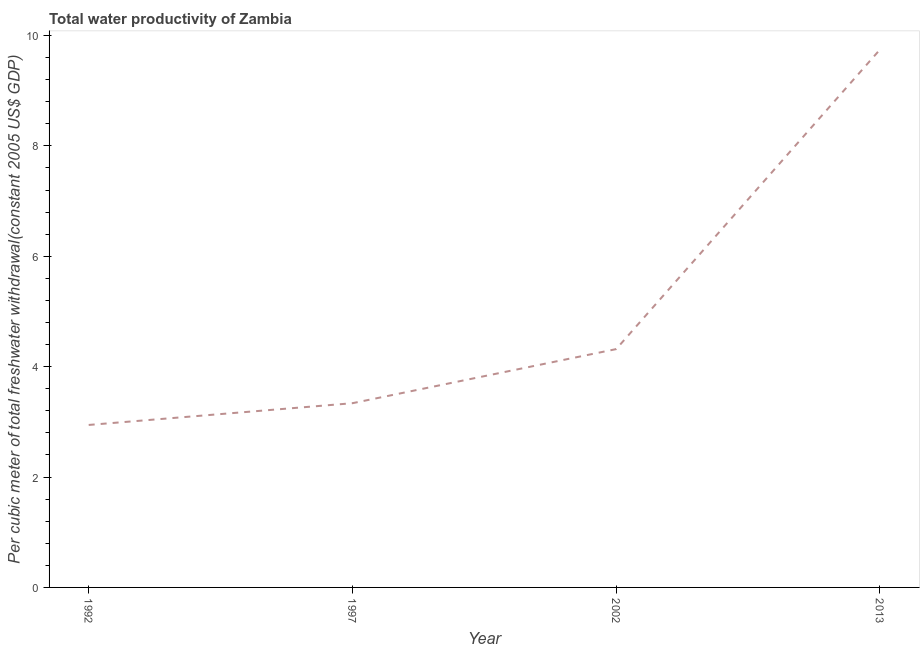What is the total water productivity in 1997?
Offer a terse response. 3.34. Across all years, what is the maximum total water productivity?
Your answer should be very brief. 9.74. Across all years, what is the minimum total water productivity?
Keep it short and to the point. 2.94. In which year was the total water productivity maximum?
Offer a terse response. 2013. What is the sum of the total water productivity?
Keep it short and to the point. 20.34. What is the difference between the total water productivity in 1992 and 1997?
Provide a short and direct response. -0.39. What is the average total water productivity per year?
Provide a short and direct response. 5.09. What is the median total water productivity?
Your response must be concise. 3.83. In how many years, is the total water productivity greater than 4 US$?
Provide a succinct answer. 2. Do a majority of the years between 1997 and 2002 (inclusive) have total water productivity greater than 1.6 US$?
Ensure brevity in your answer.  Yes. What is the ratio of the total water productivity in 2002 to that in 2013?
Provide a short and direct response. 0.44. Is the difference between the total water productivity in 1992 and 1997 greater than the difference between any two years?
Provide a succinct answer. No. What is the difference between the highest and the second highest total water productivity?
Your response must be concise. 5.43. Is the sum of the total water productivity in 1997 and 2002 greater than the maximum total water productivity across all years?
Offer a terse response. No. What is the difference between the highest and the lowest total water productivity?
Provide a short and direct response. 6.8. Does the total water productivity monotonically increase over the years?
Keep it short and to the point. Yes. Are the values on the major ticks of Y-axis written in scientific E-notation?
Provide a short and direct response. No. Does the graph contain any zero values?
Provide a succinct answer. No. What is the title of the graph?
Your response must be concise. Total water productivity of Zambia. What is the label or title of the X-axis?
Your answer should be very brief. Year. What is the label or title of the Y-axis?
Your answer should be compact. Per cubic meter of total freshwater withdrawal(constant 2005 US$ GDP). What is the Per cubic meter of total freshwater withdrawal(constant 2005 US$ GDP) in 1992?
Provide a short and direct response. 2.94. What is the Per cubic meter of total freshwater withdrawal(constant 2005 US$ GDP) of 1997?
Your response must be concise. 3.34. What is the Per cubic meter of total freshwater withdrawal(constant 2005 US$ GDP) of 2002?
Your answer should be compact. 4.32. What is the Per cubic meter of total freshwater withdrawal(constant 2005 US$ GDP) in 2013?
Provide a succinct answer. 9.74. What is the difference between the Per cubic meter of total freshwater withdrawal(constant 2005 US$ GDP) in 1992 and 1997?
Give a very brief answer. -0.39. What is the difference between the Per cubic meter of total freshwater withdrawal(constant 2005 US$ GDP) in 1992 and 2002?
Your answer should be very brief. -1.37. What is the difference between the Per cubic meter of total freshwater withdrawal(constant 2005 US$ GDP) in 1992 and 2013?
Your answer should be very brief. -6.8. What is the difference between the Per cubic meter of total freshwater withdrawal(constant 2005 US$ GDP) in 1997 and 2002?
Your answer should be compact. -0.98. What is the difference between the Per cubic meter of total freshwater withdrawal(constant 2005 US$ GDP) in 1997 and 2013?
Make the answer very short. -6.41. What is the difference between the Per cubic meter of total freshwater withdrawal(constant 2005 US$ GDP) in 2002 and 2013?
Your answer should be very brief. -5.43. What is the ratio of the Per cubic meter of total freshwater withdrawal(constant 2005 US$ GDP) in 1992 to that in 1997?
Your answer should be very brief. 0.88. What is the ratio of the Per cubic meter of total freshwater withdrawal(constant 2005 US$ GDP) in 1992 to that in 2002?
Make the answer very short. 0.68. What is the ratio of the Per cubic meter of total freshwater withdrawal(constant 2005 US$ GDP) in 1992 to that in 2013?
Ensure brevity in your answer.  0.3. What is the ratio of the Per cubic meter of total freshwater withdrawal(constant 2005 US$ GDP) in 1997 to that in 2002?
Provide a succinct answer. 0.77. What is the ratio of the Per cubic meter of total freshwater withdrawal(constant 2005 US$ GDP) in 1997 to that in 2013?
Keep it short and to the point. 0.34. What is the ratio of the Per cubic meter of total freshwater withdrawal(constant 2005 US$ GDP) in 2002 to that in 2013?
Provide a succinct answer. 0.44. 